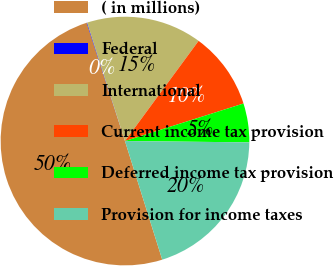<chart> <loc_0><loc_0><loc_500><loc_500><pie_chart><fcel>( in millions)<fcel>Federal<fcel>International<fcel>Current income tax provision<fcel>Deferred income tax provision<fcel>Provision for income taxes<nl><fcel>49.86%<fcel>0.07%<fcel>15.01%<fcel>10.03%<fcel>5.05%<fcel>19.99%<nl></chart> 